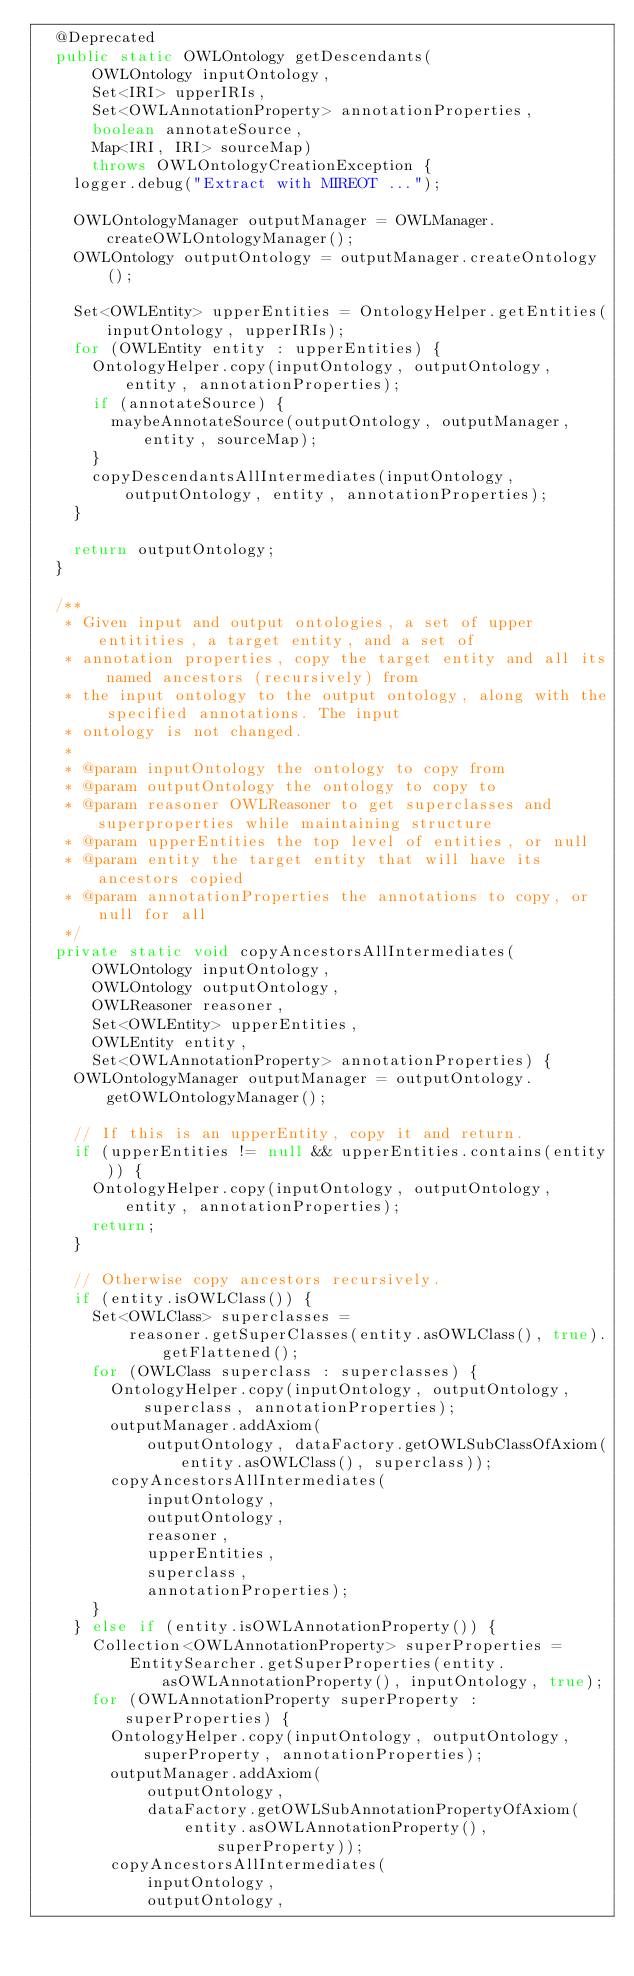Convert code to text. <code><loc_0><loc_0><loc_500><loc_500><_Java_>  @Deprecated
  public static OWLOntology getDescendants(
      OWLOntology inputOntology,
      Set<IRI> upperIRIs,
      Set<OWLAnnotationProperty> annotationProperties,
      boolean annotateSource,
      Map<IRI, IRI> sourceMap)
      throws OWLOntologyCreationException {
    logger.debug("Extract with MIREOT ...");

    OWLOntologyManager outputManager = OWLManager.createOWLOntologyManager();
    OWLOntology outputOntology = outputManager.createOntology();

    Set<OWLEntity> upperEntities = OntologyHelper.getEntities(inputOntology, upperIRIs);
    for (OWLEntity entity : upperEntities) {
      OntologyHelper.copy(inputOntology, outputOntology, entity, annotationProperties);
      if (annotateSource) {
        maybeAnnotateSource(outputOntology, outputManager, entity, sourceMap);
      }
      copyDescendantsAllIntermediates(inputOntology, outputOntology, entity, annotationProperties);
    }

    return outputOntology;
  }

  /**
   * Given input and output ontologies, a set of upper entitities, a target entity, and a set of
   * annotation properties, copy the target entity and all its named ancestors (recursively) from
   * the input ontology to the output ontology, along with the specified annotations. The input
   * ontology is not changed.
   *
   * @param inputOntology the ontology to copy from
   * @param outputOntology the ontology to copy to
   * @param reasoner OWLReasoner to get superclasses and superproperties while maintaining structure
   * @param upperEntities the top level of entities, or null
   * @param entity the target entity that will have its ancestors copied
   * @param annotationProperties the annotations to copy, or null for all
   */
  private static void copyAncestorsAllIntermediates(
      OWLOntology inputOntology,
      OWLOntology outputOntology,
      OWLReasoner reasoner,
      Set<OWLEntity> upperEntities,
      OWLEntity entity,
      Set<OWLAnnotationProperty> annotationProperties) {
    OWLOntologyManager outputManager = outputOntology.getOWLOntologyManager();

    // If this is an upperEntity, copy it and return.
    if (upperEntities != null && upperEntities.contains(entity)) {
      OntologyHelper.copy(inputOntology, outputOntology, entity, annotationProperties);
      return;
    }

    // Otherwise copy ancestors recursively.
    if (entity.isOWLClass()) {
      Set<OWLClass> superclasses =
          reasoner.getSuperClasses(entity.asOWLClass(), true).getFlattened();
      for (OWLClass superclass : superclasses) {
        OntologyHelper.copy(inputOntology, outputOntology, superclass, annotationProperties);
        outputManager.addAxiom(
            outputOntology, dataFactory.getOWLSubClassOfAxiom(entity.asOWLClass(), superclass));
        copyAncestorsAllIntermediates(
            inputOntology,
            outputOntology,
            reasoner,
            upperEntities,
            superclass,
            annotationProperties);
      }
    } else if (entity.isOWLAnnotationProperty()) {
      Collection<OWLAnnotationProperty> superProperties =
          EntitySearcher.getSuperProperties(entity.asOWLAnnotationProperty(), inputOntology, true);
      for (OWLAnnotationProperty superProperty : superProperties) {
        OntologyHelper.copy(inputOntology, outputOntology, superProperty, annotationProperties);
        outputManager.addAxiom(
            outputOntology,
            dataFactory.getOWLSubAnnotationPropertyOfAxiom(
                entity.asOWLAnnotationProperty(), superProperty));
        copyAncestorsAllIntermediates(
            inputOntology,
            outputOntology,</code> 